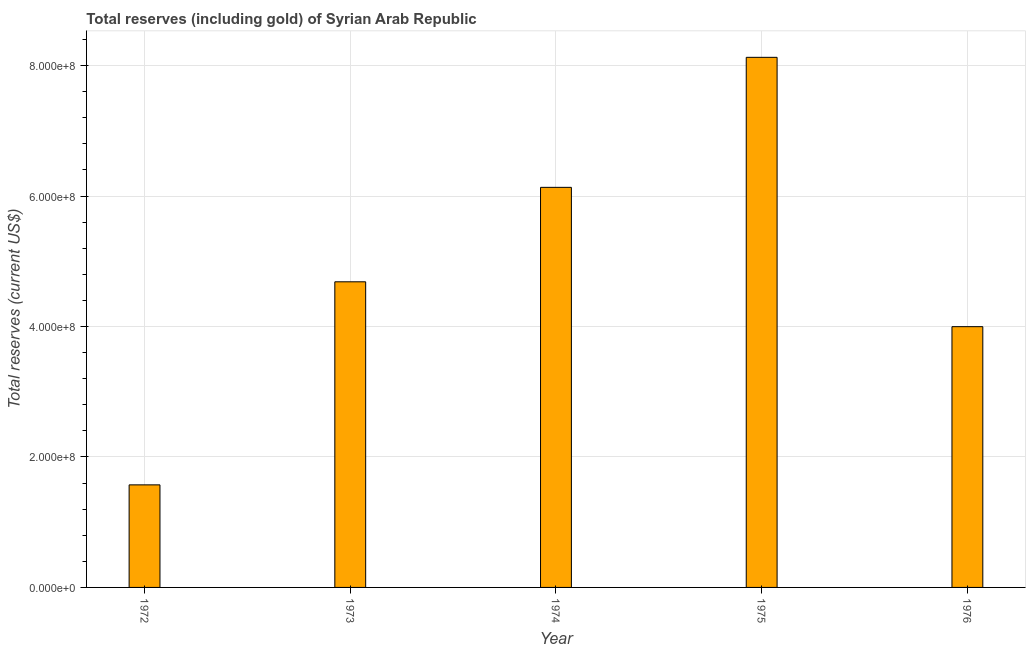Does the graph contain any zero values?
Your response must be concise. No. What is the title of the graph?
Your answer should be compact. Total reserves (including gold) of Syrian Arab Republic. What is the label or title of the Y-axis?
Make the answer very short. Total reserves (current US$). What is the total reserves (including gold) in 1972?
Keep it short and to the point. 1.57e+08. Across all years, what is the maximum total reserves (including gold)?
Keep it short and to the point. 8.13e+08. Across all years, what is the minimum total reserves (including gold)?
Your answer should be compact. 1.57e+08. In which year was the total reserves (including gold) maximum?
Provide a succinct answer. 1975. What is the sum of the total reserves (including gold)?
Your response must be concise. 2.45e+09. What is the difference between the total reserves (including gold) in 1973 and 1975?
Offer a very short reply. -3.44e+08. What is the average total reserves (including gold) per year?
Keep it short and to the point. 4.90e+08. What is the median total reserves (including gold)?
Offer a terse response. 4.68e+08. What is the ratio of the total reserves (including gold) in 1973 to that in 1976?
Your answer should be compact. 1.17. Is the difference between the total reserves (including gold) in 1975 and 1976 greater than the difference between any two years?
Offer a terse response. No. What is the difference between the highest and the second highest total reserves (including gold)?
Your answer should be very brief. 1.99e+08. What is the difference between the highest and the lowest total reserves (including gold)?
Make the answer very short. 6.55e+08. In how many years, is the total reserves (including gold) greater than the average total reserves (including gold) taken over all years?
Make the answer very short. 2. How many bars are there?
Offer a very short reply. 5. Are all the bars in the graph horizontal?
Ensure brevity in your answer.  No. How many years are there in the graph?
Your response must be concise. 5. Are the values on the major ticks of Y-axis written in scientific E-notation?
Ensure brevity in your answer.  Yes. What is the Total reserves (current US$) in 1972?
Your answer should be compact. 1.57e+08. What is the Total reserves (current US$) in 1973?
Your answer should be very brief. 4.68e+08. What is the Total reserves (current US$) in 1974?
Give a very brief answer. 6.13e+08. What is the Total reserves (current US$) in 1975?
Your response must be concise. 8.13e+08. What is the Total reserves (current US$) in 1976?
Offer a very short reply. 4.00e+08. What is the difference between the Total reserves (current US$) in 1972 and 1973?
Give a very brief answer. -3.11e+08. What is the difference between the Total reserves (current US$) in 1972 and 1974?
Make the answer very short. -4.56e+08. What is the difference between the Total reserves (current US$) in 1972 and 1975?
Provide a succinct answer. -6.55e+08. What is the difference between the Total reserves (current US$) in 1972 and 1976?
Your response must be concise. -2.42e+08. What is the difference between the Total reserves (current US$) in 1973 and 1974?
Offer a very short reply. -1.45e+08. What is the difference between the Total reserves (current US$) in 1973 and 1975?
Provide a short and direct response. -3.44e+08. What is the difference between the Total reserves (current US$) in 1973 and 1976?
Your response must be concise. 6.88e+07. What is the difference between the Total reserves (current US$) in 1974 and 1975?
Make the answer very short. -1.99e+08. What is the difference between the Total reserves (current US$) in 1974 and 1976?
Your answer should be compact. 2.14e+08. What is the difference between the Total reserves (current US$) in 1975 and 1976?
Your response must be concise. 4.13e+08. What is the ratio of the Total reserves (current US$) in 1972 to that in 1973?
Provide a short and direct response. 0.34. What is the ratio of the Total reserves (current US$) in 1972 to that in 1974?
Offer a very short reply. 0.26. What is the ratio of the Total reserves (current US$) in 1972 to that in 1975?
Provide a succinct answer. 0.19. What is the ratio of the Total reserves (current US$) in 1972 to that in 1976?
Make the answer very short. 0.39. What is the ratio of the Total reserves (current US$) in 1973 to that in 1974?
Provide a short and direct response. 0.76. What is the ratio of the Total reserves (current US$) in 1973 to that in 1975?
Provide a short and direct response. 0.58. What is the ratio of the Total reserves (current US$) in 1973 to that in 1976?
Give a very brief answer. 1.17. What is the ratio of the Total reserves (current US$) in 1974 to that in 1975?
Ensure brevity in your answer.  0.76. What is the ratio of the Total reserves (current US$) in 1974 to that in 1976?
Keep it short and to the point. 1.53. What is the ratio of the Total reserves (current US$) in 1975 to that in 1976?
Make the answer very short. 2.03. 